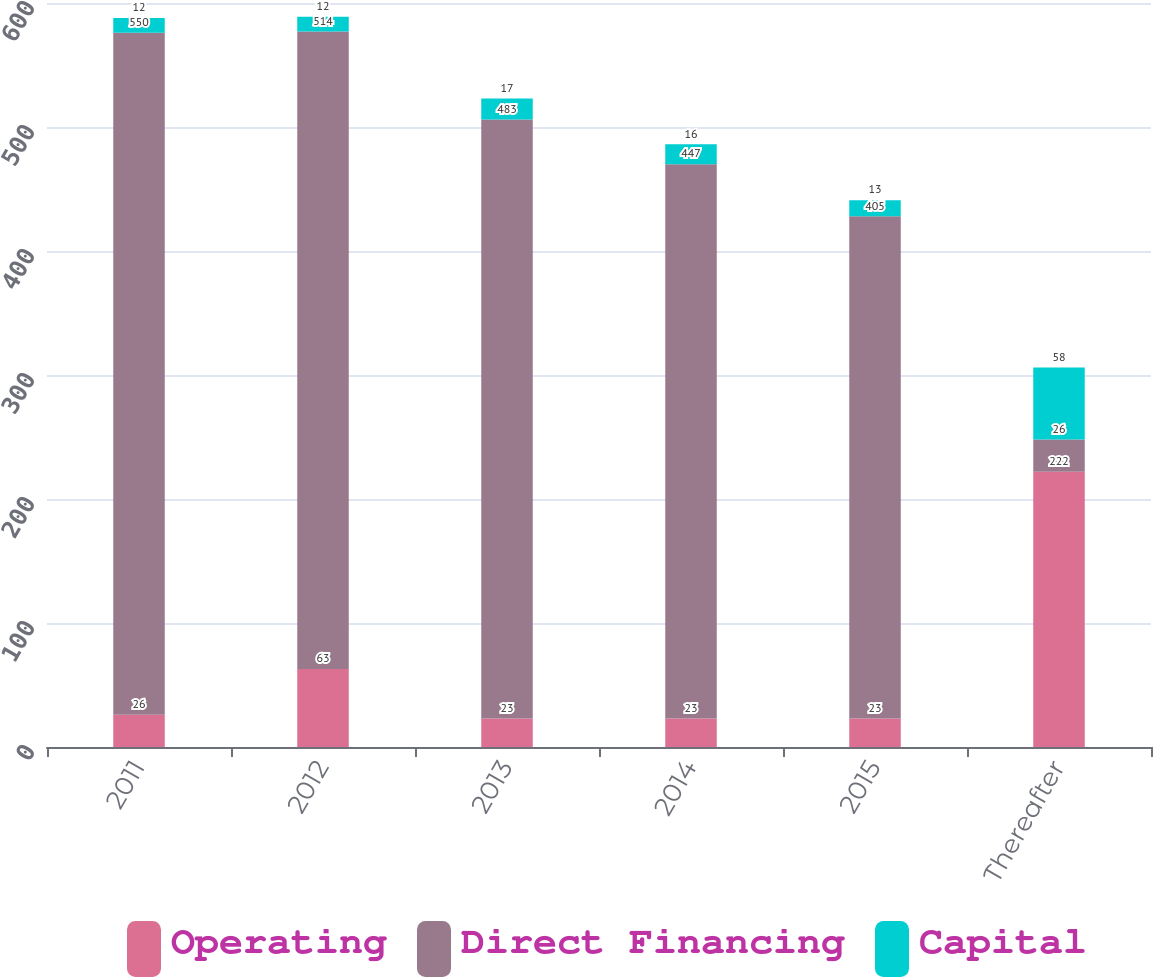<chart> <loc_0><loc_0><loc_500><loc_500><stacked_bar_chart><ecel><fcel>2011<fcel>2012<fcel>2013<fcel>2014<fcel>2015<fcel>Thereafter<nl><fcel>Operating<fcel>26<fcel>63<fcel>23<fcel>23<fcel>23<fcel>222<nl><fcel>Direct Financing<fcel>550<fcel>514<fcel>483<fcel>447<fcel>405<fcel>26<nl><fcel>Capital<fcel>12<fcel>12<fcel>17<fcel>16<fcel>13<fcel>58<nl></chart> 